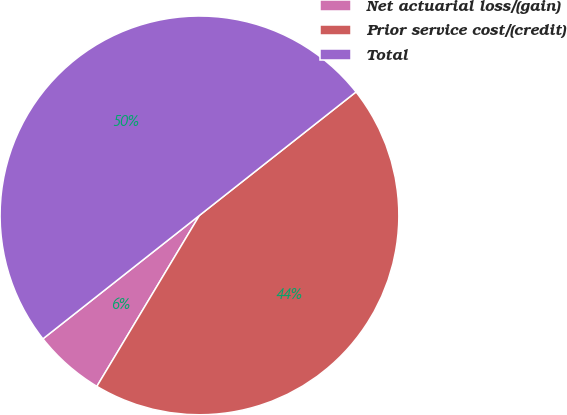Convert chart. <chart><loc_0><loc_0><loc_500><loc_500><pie_chart><fcel>Net actuarial loss/(gain)<fcel>Prior service cost/(credit)<fcel>Total<nl><fcel>5.77%<fcel>44.23%<fcel>50.0%<nl></chart> 